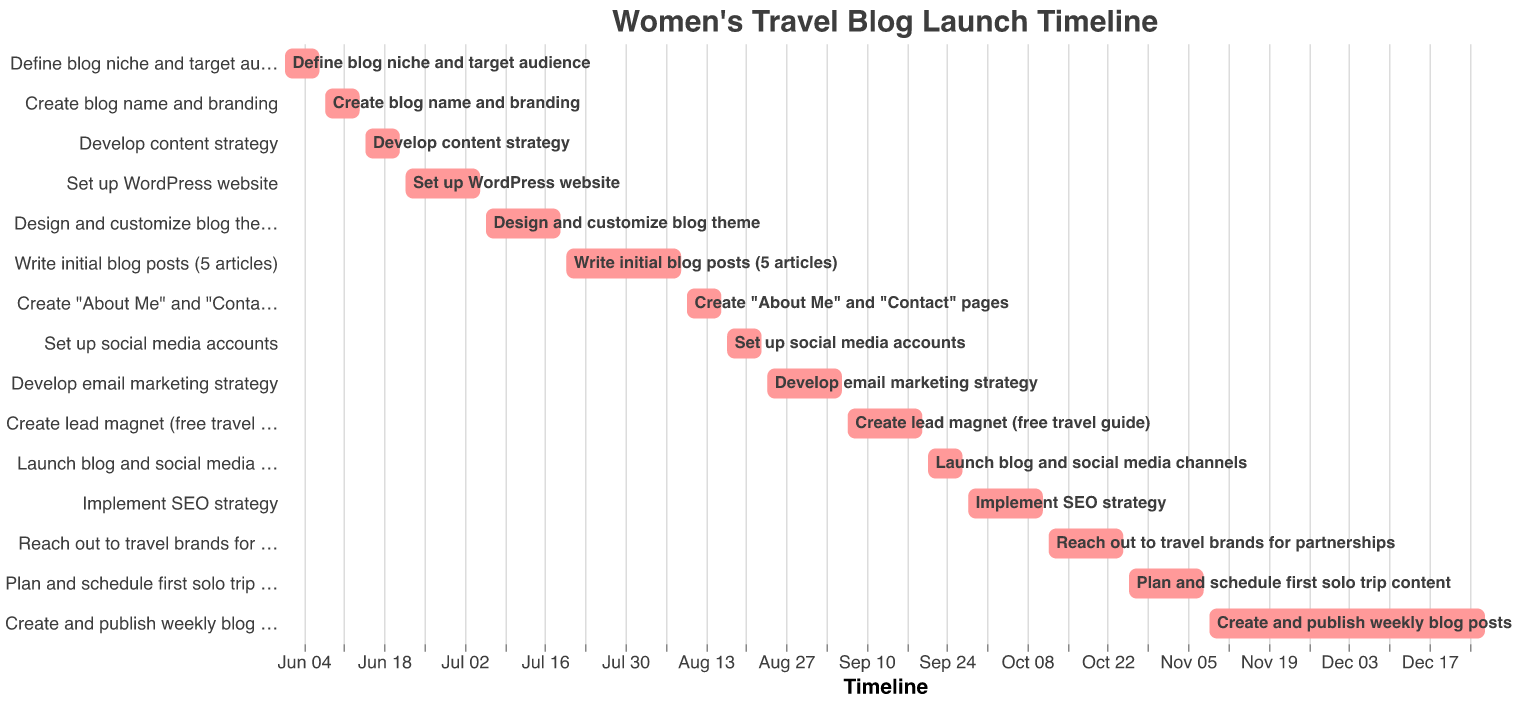What is the title of the Gantt Chart? The title is located at the top of the chart and clearly states its purpose.
Answer: Women's Travel Blog Launch Timeline When does the task "Set up WordPress website" start and end? You can find the start and end dates by checking the position of the task bar labeled "Set up WordPress website" on the horizontal timeline axis.
Answer: June 22 to July 5 Which task has the longest duration? To find this, compare the lengths of all the task bars. The longest bar represents the task with the longest duration.
Answer: Create and publish weekly blog posts How many tasks are planned for July? Identify the tasks that have their bars starting or ending within the month of July by examining the horizontal timeline.
Answer: 3 tasks Which comes first: "Develop content strategy" or "Create lead magnet (free travel guide)"? By looking at the timeline, compare the start dates of the two tasks. The one with an earlier start date comes first.
Answer: Develop content strategy How many days are allocated to "Write initial blog posts (5 articles)"? Subtract the start date from the end date for the task to get the number of days allocated.
Answer: 20 days What is the last task on the timeline? Check the bottom-most bar on the vertical axis of the Gantt Chart.
Answer: Create and publish weekly blog posts Which tasks specifically relate to marketing? Identify tasks on the chart that mention marketing or related activities in their names.
Answer: Develop email marketing strategy, Set up social media accounts, Create lead magnet (free travel guide), Implement SEO strategy Are there any overlapping tasks in August? Examine the bars for the month of August on the timeline to see if any start before another ends.
Answer: Yes By how many days does "Define blog niche and target audience" end before "Create blog name and branding" starts? Calculate the difference between the end date of "Define blog niche and target audience" and the start date of "Create blog name and branding".
Answer: 1 day 